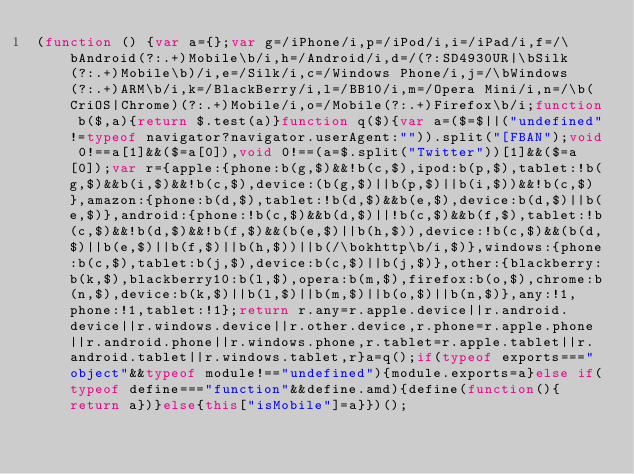<code> <loc_0><loc_0><loc_500><loc_500><_JavaScript_>(function () {var a={};var g=/iPhone/i,p=/iPod/i,i=/iPad/i,f=/\bAndroid(?:.+)Mobile\b/i,h=/Android/i,d=/(?:SD4930UR|\bSilk(?:.+)Mobile\b)/i,e=/Silk/i,c=/Windows Phone/i,j=/\bWindows(?:.+)ARM\b/i,k=/BlackBerry/i,l=/BB10/i,m=/Opera Mini/i,n=/\b(CriOS|Chrome)(?:.+)Mobile/i,o=/Mobile(?:.+)Firefox\b/i;function b($,a){return $.test(a)}function q($){var a=($=$||("undefined"!=typeof navigator?navigator.userAgent:"")).split("[FBAN");void 0!==a[1]&&($=a[0]),void 0!==(a=$.split("Twitter"))[1]&&($=a[0]);var r={apple:{phone:b(g,$)&&!b(c,$),ipod:b(p,$),tablet:!b(g,$)&&b(i,$)&&!b(c,$),device:(b(g,$)||b(p,$)||b(i,$))&&!b(c,$)},amazon:{phone:b(d,$),tablet:!b(d,$)&&b(e,$),device:b(d,$)||b(e,$)},android:{phone:!b(c,$)&&b(d,$)||!b(c,$)&&b(f,$),tablet:!b(c,$)&&!b(d,$)&&!b(f,$)&&(b(e,$)||b(h,$)),device:!b(c,$)&&(b(d,$)||b(e,$)||b(f,$)||b(h,$))||b(/\bokhttp\b/i,$)},windows:{phone:b(c,$),tablet:b(j,$),device:b(c,$)||b(j,$)},other:{blackberry:b(k,$),blackberry10:b(l,$),opera:b(m,$),firefox:b(o,$),chrome:b(n,$),device:b(k,$)||b(l,$)||b(m,$)||b(o,$)||b(n,$)},any:!1,phone:!1,tablet:!1};return r.any=r.apple.device||r.android.device||r.windows.device||r.other.device,r.phone=r.apple.phone||r.android.phone||r.windows.phone,r.tablet=r.apple.tablet||r.android.tablet||r.windows.tablet,r}a=q();if(typeof exports==="object"&&typeof module!=="undefined"){module.exports=a}else if(typeof define==="function"&&define.amd){define(function(){return a})}else{this["isMobile"]=a}})();</code> 